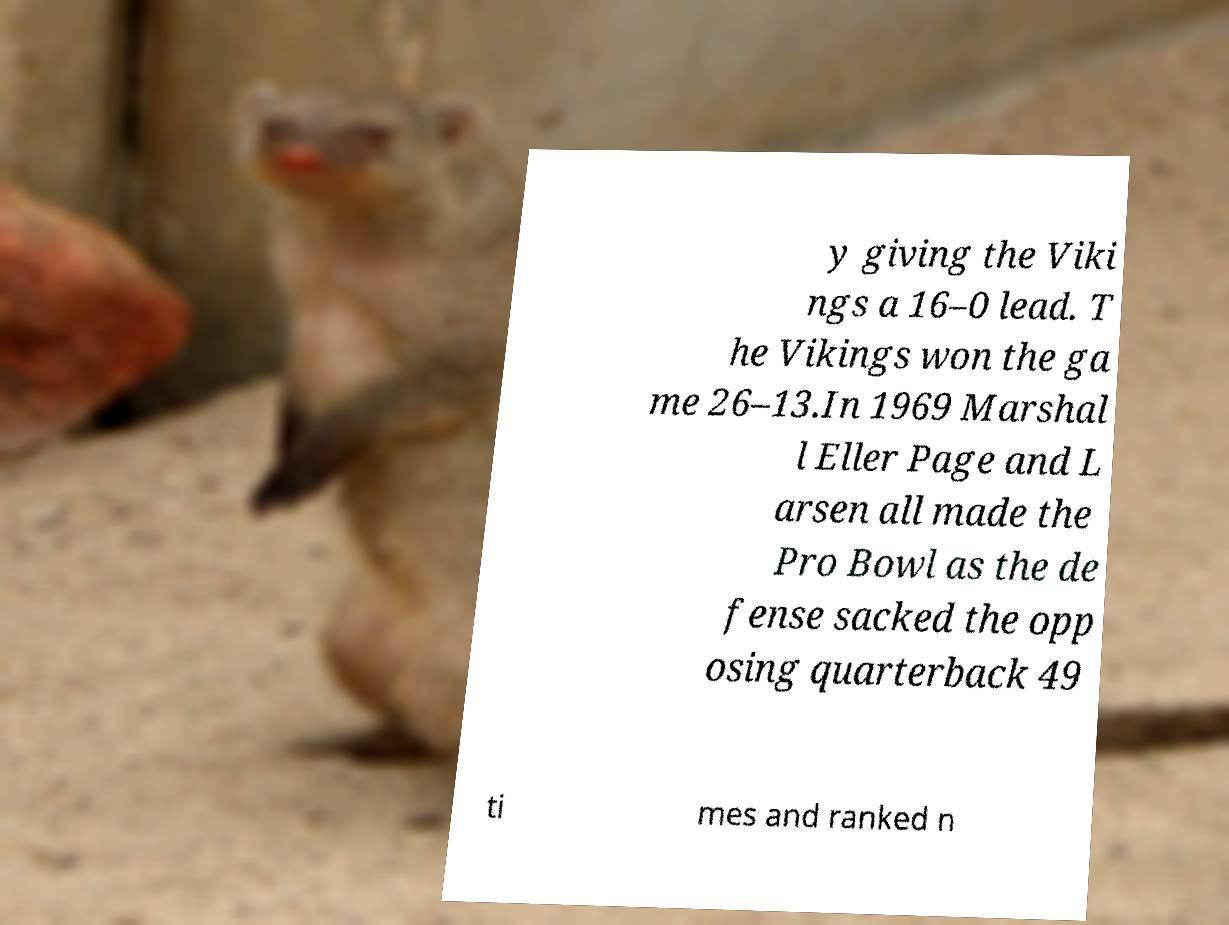Please identify and transcribe the text found in this image. y giving the Viki ngs a 16–0 lead. T he Vikings won the ga me 26–13.In 1969 Marshal l Eller Page and L arsen all made the Pro Bowl as the de fense sacked the opp osing quarterback 49 ti mes and ranked n 